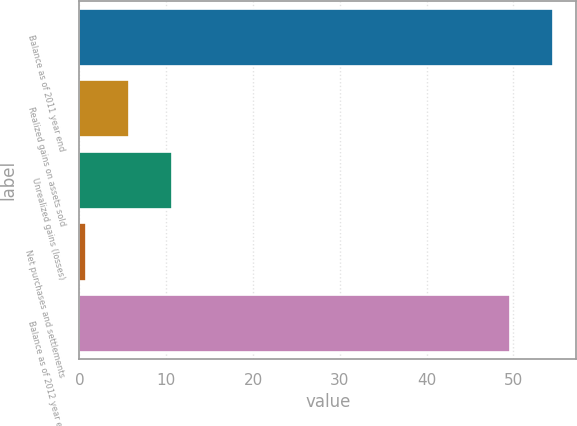Convert chart to OTSL. <chart><loc_0><loc_0><loc_500><loc_500><bar_chart><fcel>Balance as of 2011 year end<fcel>Realized gains on assets sold<fcel>Unrealized gains (losses)<fcel>Net purchases and settlements<fcel>Balance as of 2012 year end<nl><fcel>54.51<fcel>5.71<fcel>10.62<fcel>0.8<fcel>49.6<nl></chart> 